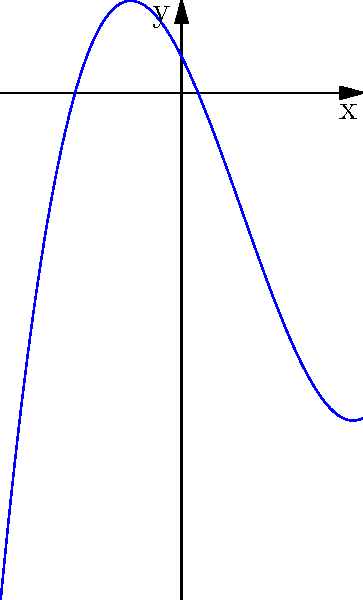As an artist and sculptor, you're designing a large-scale installation inspired by mathematical curves. You come across a polynomial function graph that intrigues you. Based on the graph shown, determine the end behavior of this polynomial function as $x$ approaches positive and negative infinity. To determine the end behavior of a polynomial function, we need to analyze how the graph behaves as $x$ approaches positive and negative infinity. Let's break it down step-by-step:

1. Observe the graph's overall shape: It appears to be a cubic function (degree 3 polynomial) due to its S-like curve.

2. Look at the left side of the graph (as $x \to -\infty$):
   The curve descends sharply, approaching negative infinity.

3. Look at the right side of the graph (as $x \to +\infty$):
   The curve ascends sharply, approaching positive infinity.

4. For a polynomial of odd degree (like a cubic function):
   - If the leading coefficient is positive, the end behavior is:
     As $x \to -\infty$, $f(x) \to -\infty$, and as $x \to +\infty$, $f(x) \to +\infty$

5. The graph matches this behavior, indicating a positive leading coefficient.

6. We can express this end behavior using limit notation:
   $\lim_{x \to -\infty} f(x) = -\infty$ and $\lim_{x \to +\infty} f(x) = +\infty$

This end behavior is characteristic of cubic functions with a positive leading coefficient, which aligns with the artistic S-curve shape you're observing for your installation design.
Answer: As $x \to -\infty$, $f(x) \to -\infty$; as $x \to +\infty$, $f(x) \to +\infty$ 